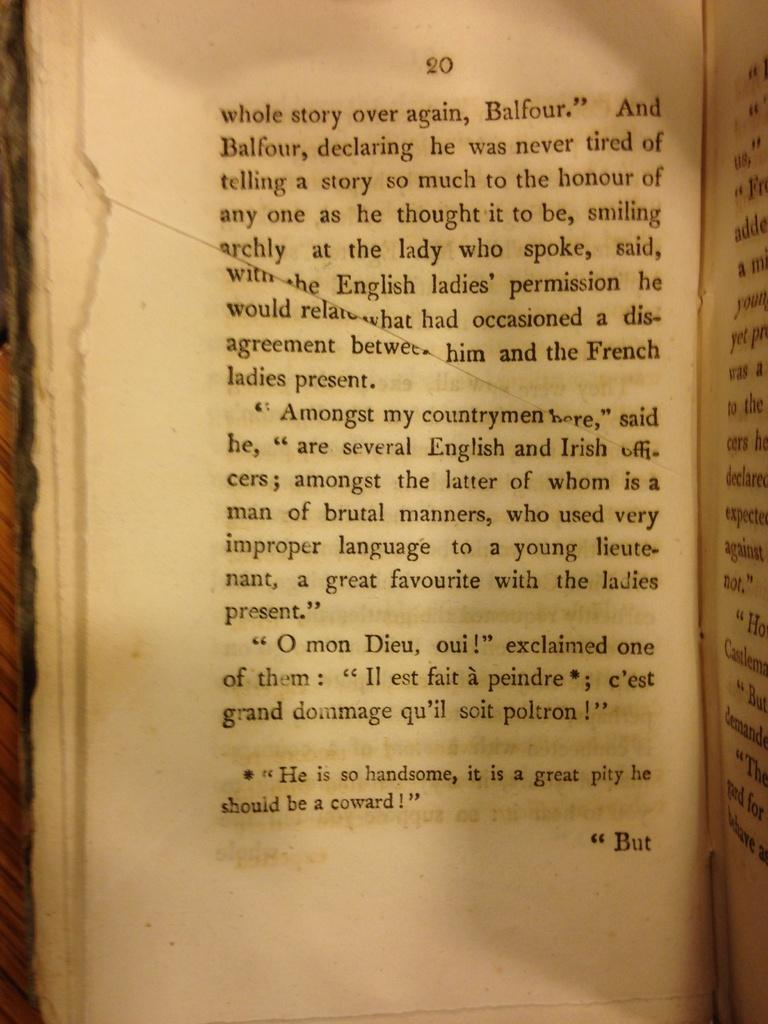<image>
Give a short and clear explanation of the subsequent image. A page about somebody called Balfour, with French text at the bottom. 